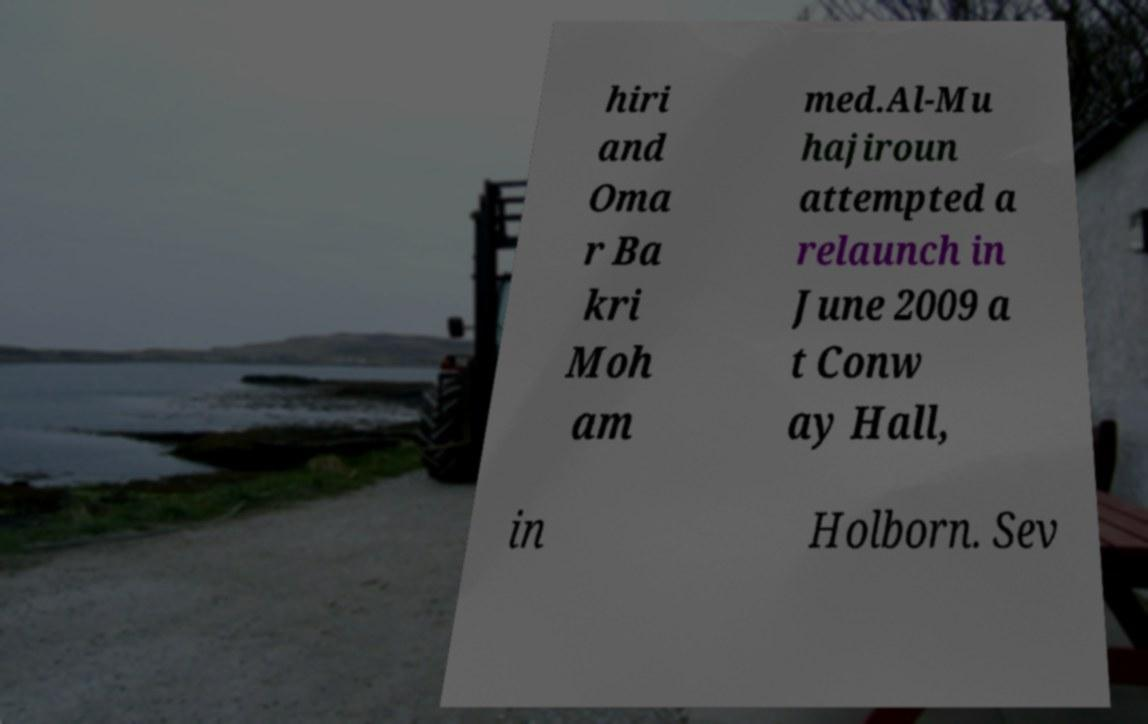Could you assist in decoding the text presented in this image and type it out clearly? hiri and Oma r Ba kri Moh am med.Al-Mu hajiroun attempted a relaunch in June 2009 a t Conw ay Hall, in Holborn. Sev 